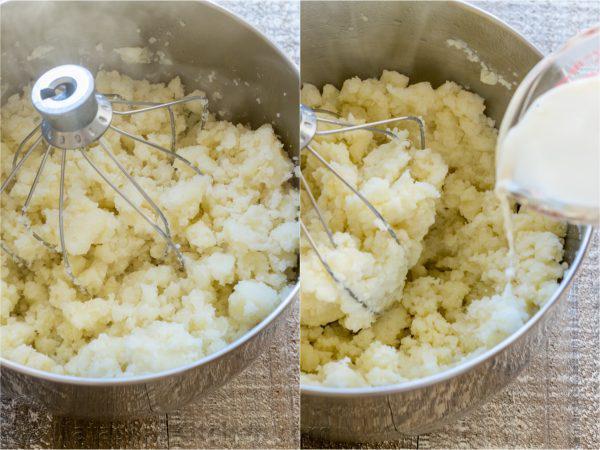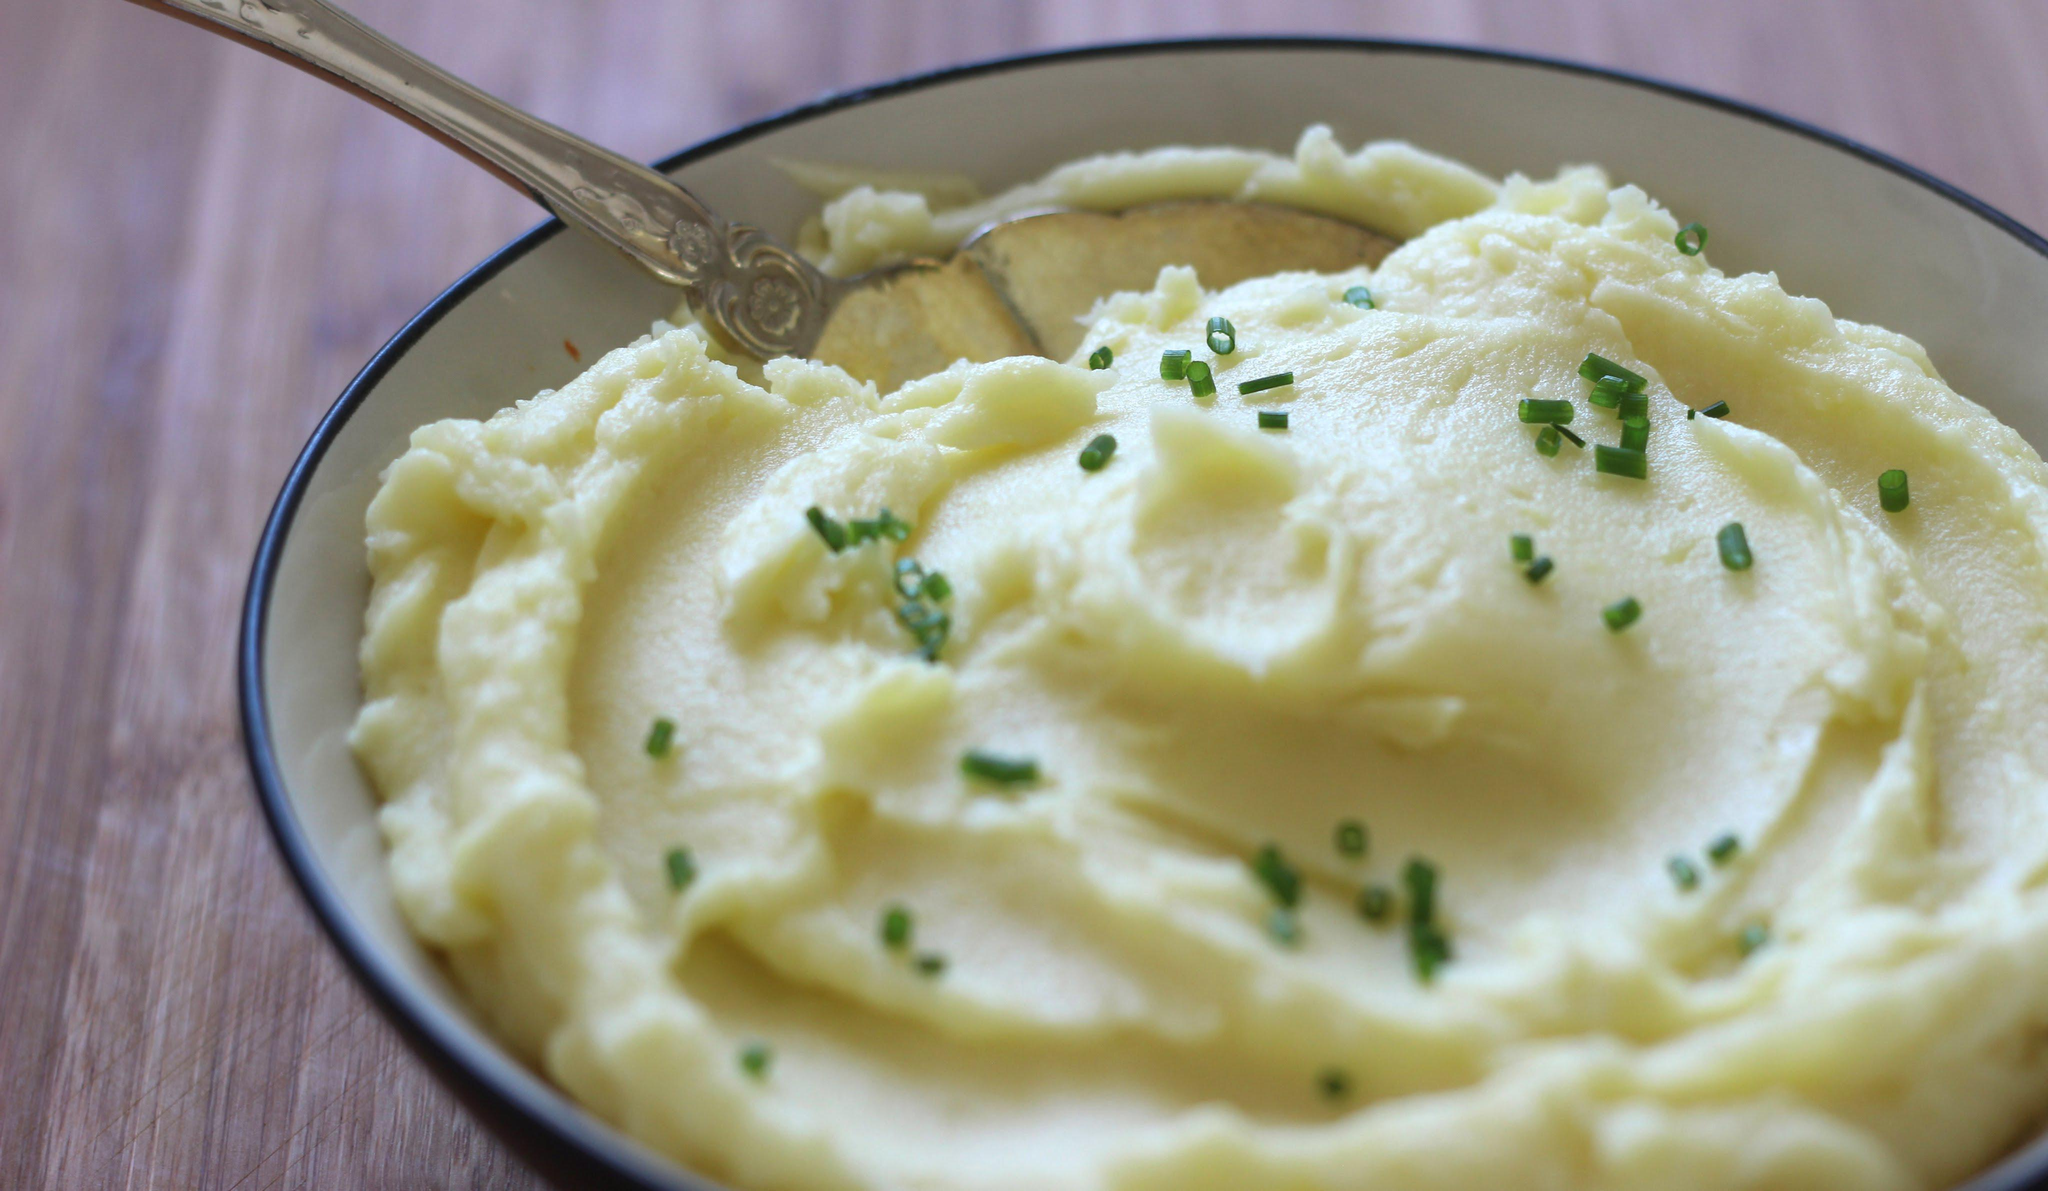The first image is the image on the left, the second image is the image on the right. Given the left and right images, does the statement "A handle is sticking out of the round bowl of potatoes in the right image." hold true? Answer yes or no. Yes. 